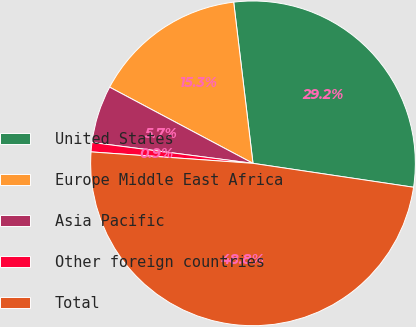<chart> <loc_0><loc_0><loc_500><loc_500><pie_chart><fcel>United States<fcel>Europe Middle East Africa<fcel>Asia Pacific<fcel>Other foreign countries<fcel>Total<nl><fcel>29.25%<fcel>15.33%<fcel>5.72%<fcel>0.93%<fcel>48.77%<nl></chart> 